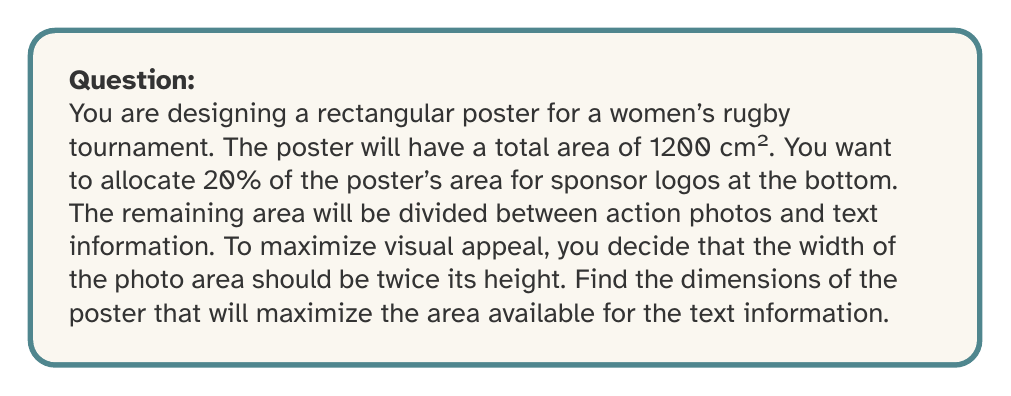Show me your answer to this math problem. Let's approach this step-by-step using calculus:

1) Let $w$ be the width and $h$ be the height of the poster.

2) Given that the total area is 1200 cm², we can write:
   $$ wh = 1200 $$

3) The sponsor area is 20% of the total, so the remaining 80% is for photos and text:
   $$ 0.8wh = 960 $$

4) Let $x$ be the height of the photo area. Its width is $2x$ (as specified in the question).
   The area of the photo section is thus $2x^2$.

5) The area available for text (which we want to maximize) is:
   $$ A_{text} = 960 - 2x^2 $$

6) We need to express this in terms of one variable. We can use the constraint $wh = 1200$:
   $$ w = \frac{1200}{h} $$

7) The width of the photo area ($2x$) plus the height of the poster ($h$) should equal the width of the poster:
   $$ 2x + h = \frac{1200}{h} $$

8) Solving for $x$:
   $$ x = \frac{600}{h} - \frac{h}{2} $$

9) Substituting this into our area function:
   $$ A_{text} = 960 - 2(\frac{600}{h} - \frac{h}{2})^2 $$

10) To find the maximum, we differentiate and set to zero:
    $$ \frac{dA_{text}}{dh} = -2 \cdot 2 \cdot (\frac{600}{h} - \frac{h}{2}) \cdot (-\frac{600}{h^2} - \frac{1}{2}) = 0 $$

11) Solving this equation (omitting intermediate steps for brevity):
    $$ h = 20\sqrt{6} \approx 48.99 \text{ cm} $$

12) The corresponding width is:
    $$ w = \frac{1200}{h} = \frac{1200}{20\sqrt{6}} = 10\sqrt{6} \approx 24.49 \text{ cm} $$

Therefore, the optimal dimensions for the poster are approximately 48.99 cm x 24.49 cm.
Answer: $48.99 \text{ cm} \times 24.49 \text{ cm}$ 